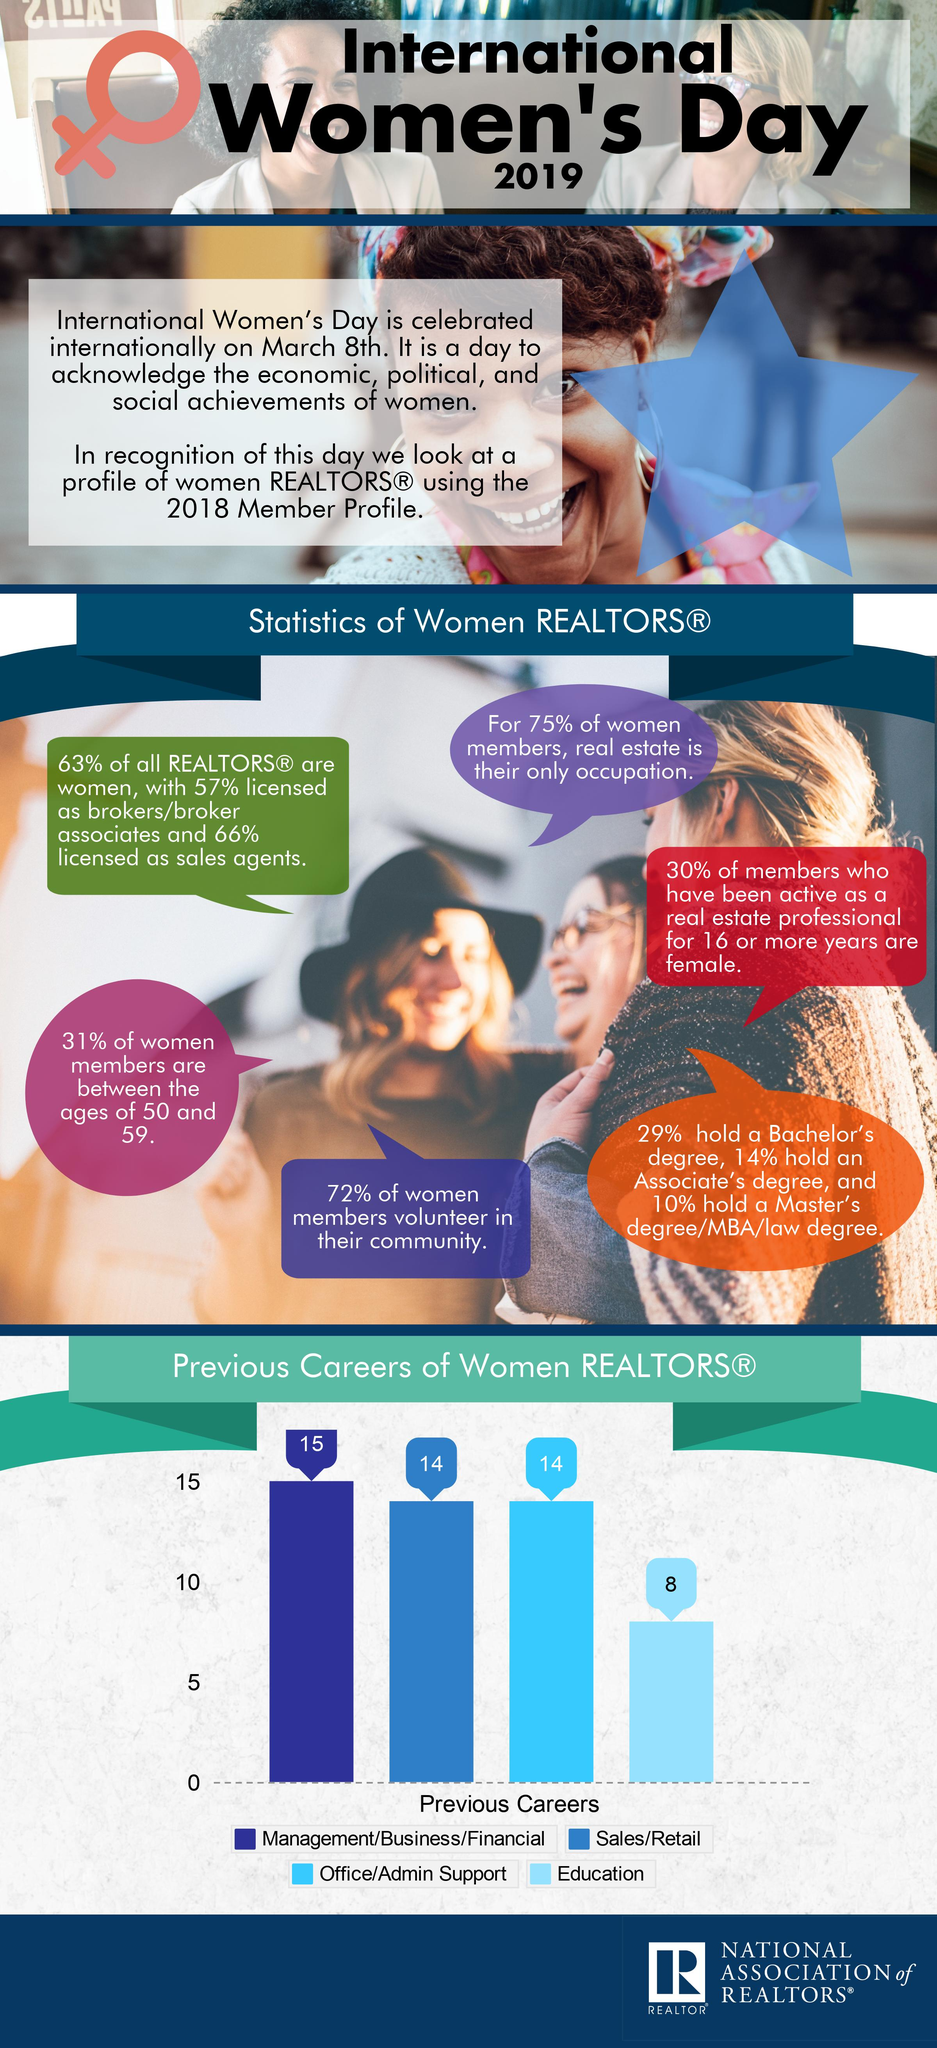List a handful of essential elements in this visual. According to the data, 69% of women members are not between the ages of 50 and 59. Of the total number of individuals surveyed, 34% were not licensed as sales agents. According to the data, 43% of individuals in the industry are not licensed as brokers. According to the data, 71% of women did not hold a Bachelor's degree. According to a recent survey, 37% of Realtors are not women. 